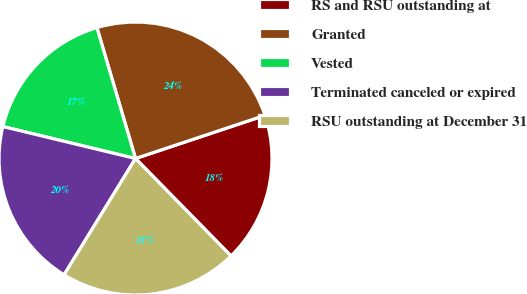Convert chart to OTSL. <chart><loc_0><loc_0><loc_500><loc_500><pie_chart><fcel>RS and RSU outstanding at<fcel>Granted<fcel>Vested<fcel>Terminated canceled or expired<fcel>RSU outstanding at December 31<nl><fcel>17.78%<fcel>24.44%<fcel>16.67%<fcel>20.0%<fcel>21.11%<nl></chart> 